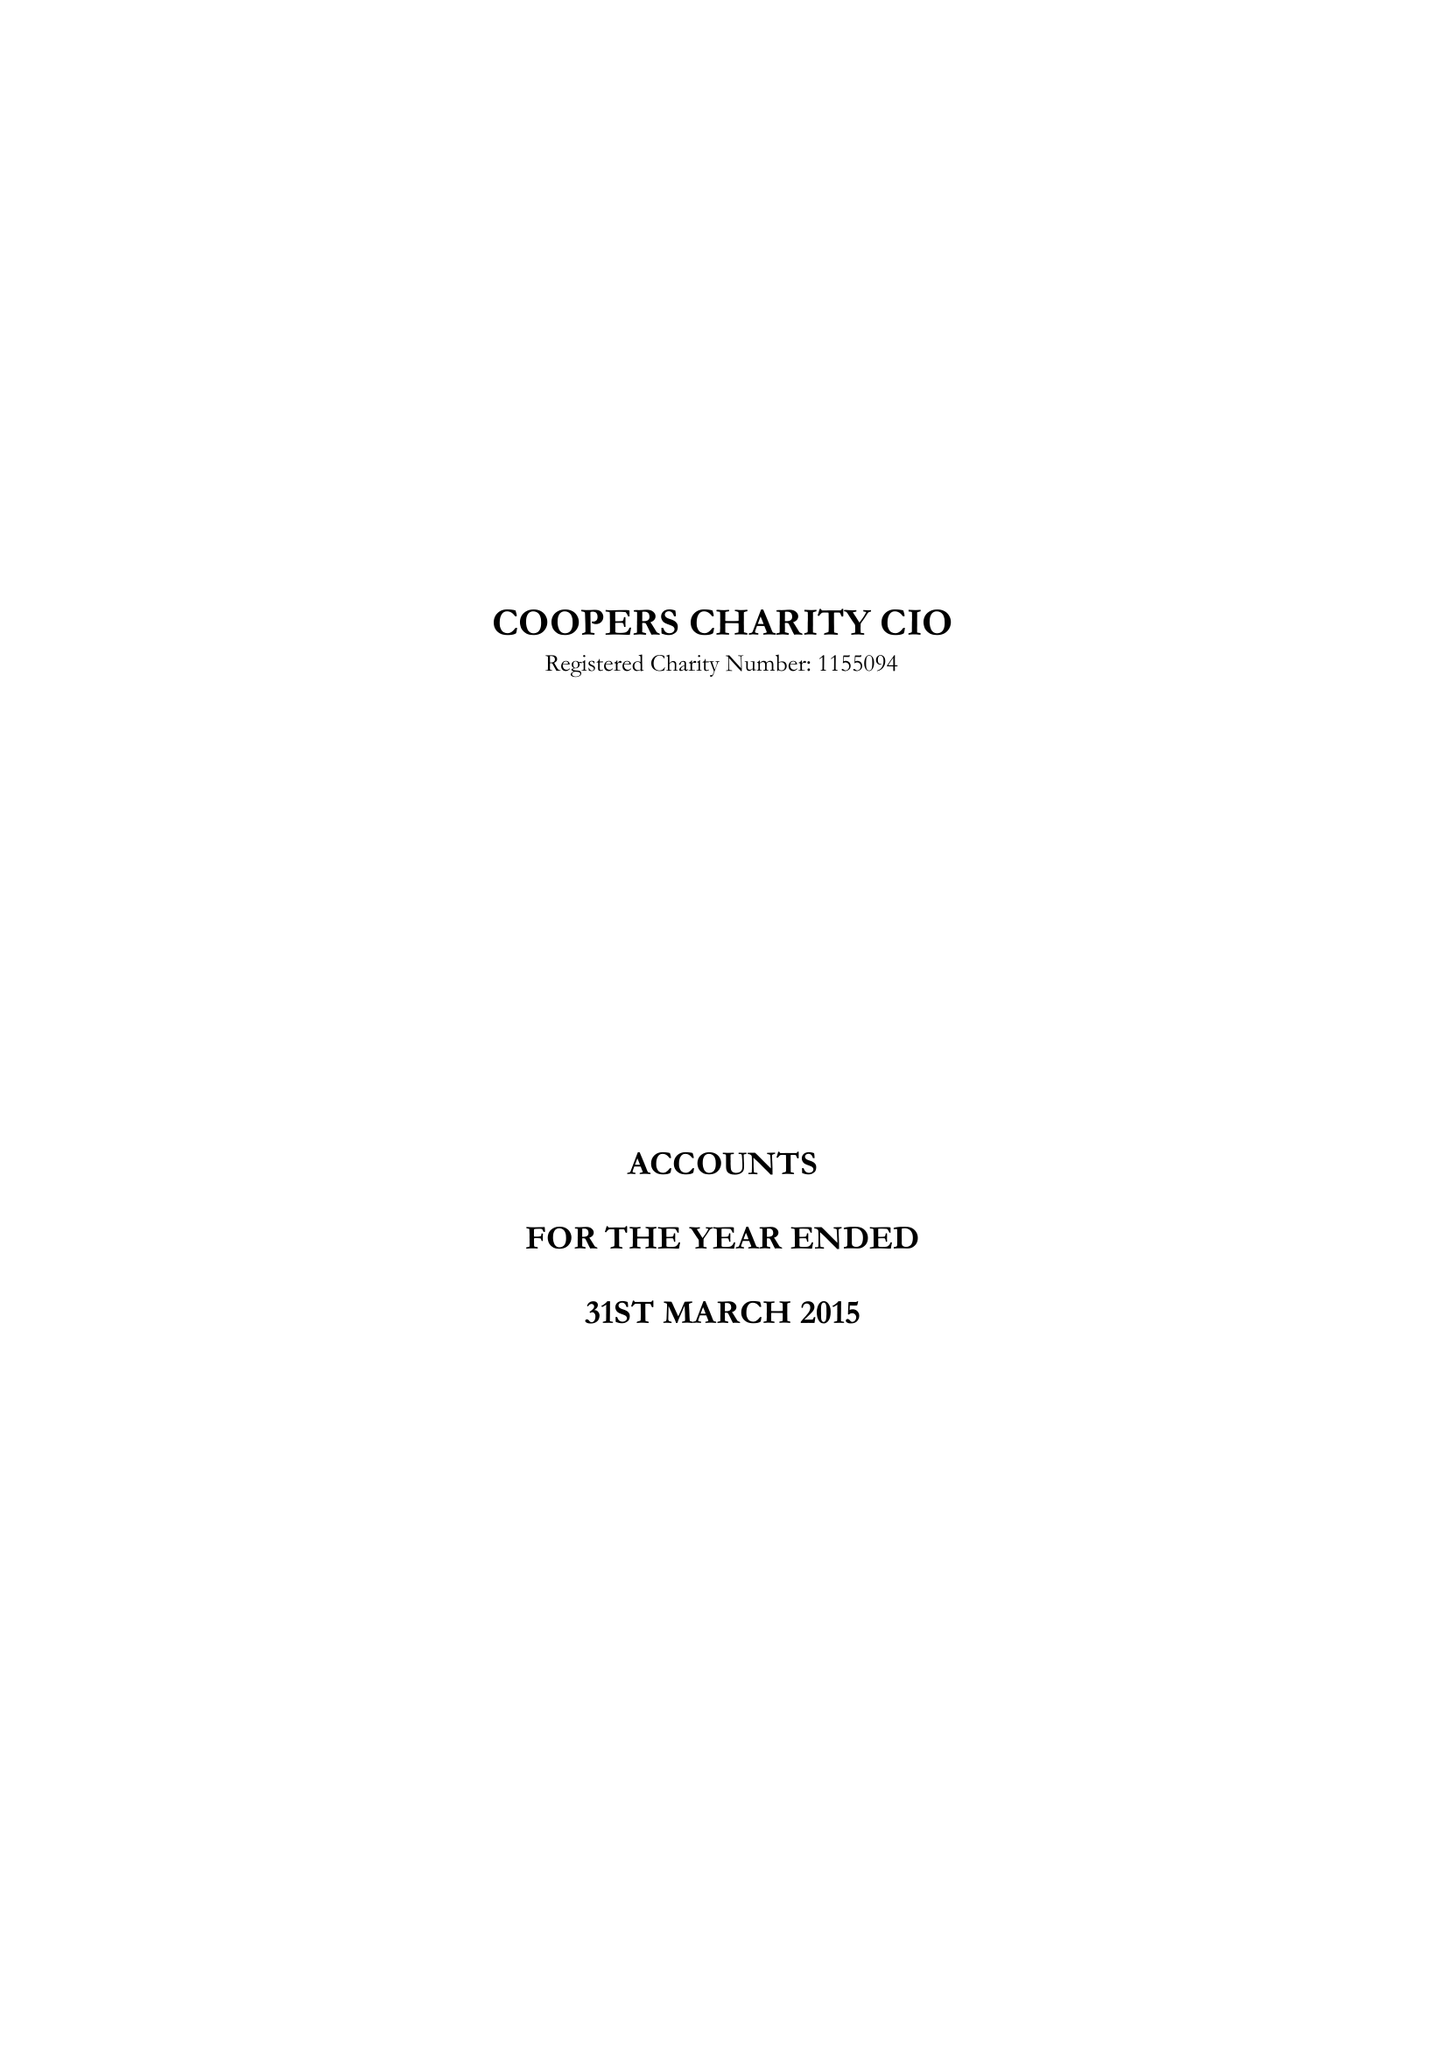What is the value for the address__post_town?
Answer the question using a single word or phrase. LONDON 